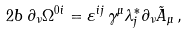<formula> <loc_0><loc_0><loc_500><loc_500>2 b \, \partial _ { \nu } \Omega ^ { 0 i } = \varepsilon ^ { i j } \, \gamma ^ { \mu } \lambda _ { j } ^ { * } \partial _ { \nu } { \tilde { A } } _ { \mu } \, ,</formula> 